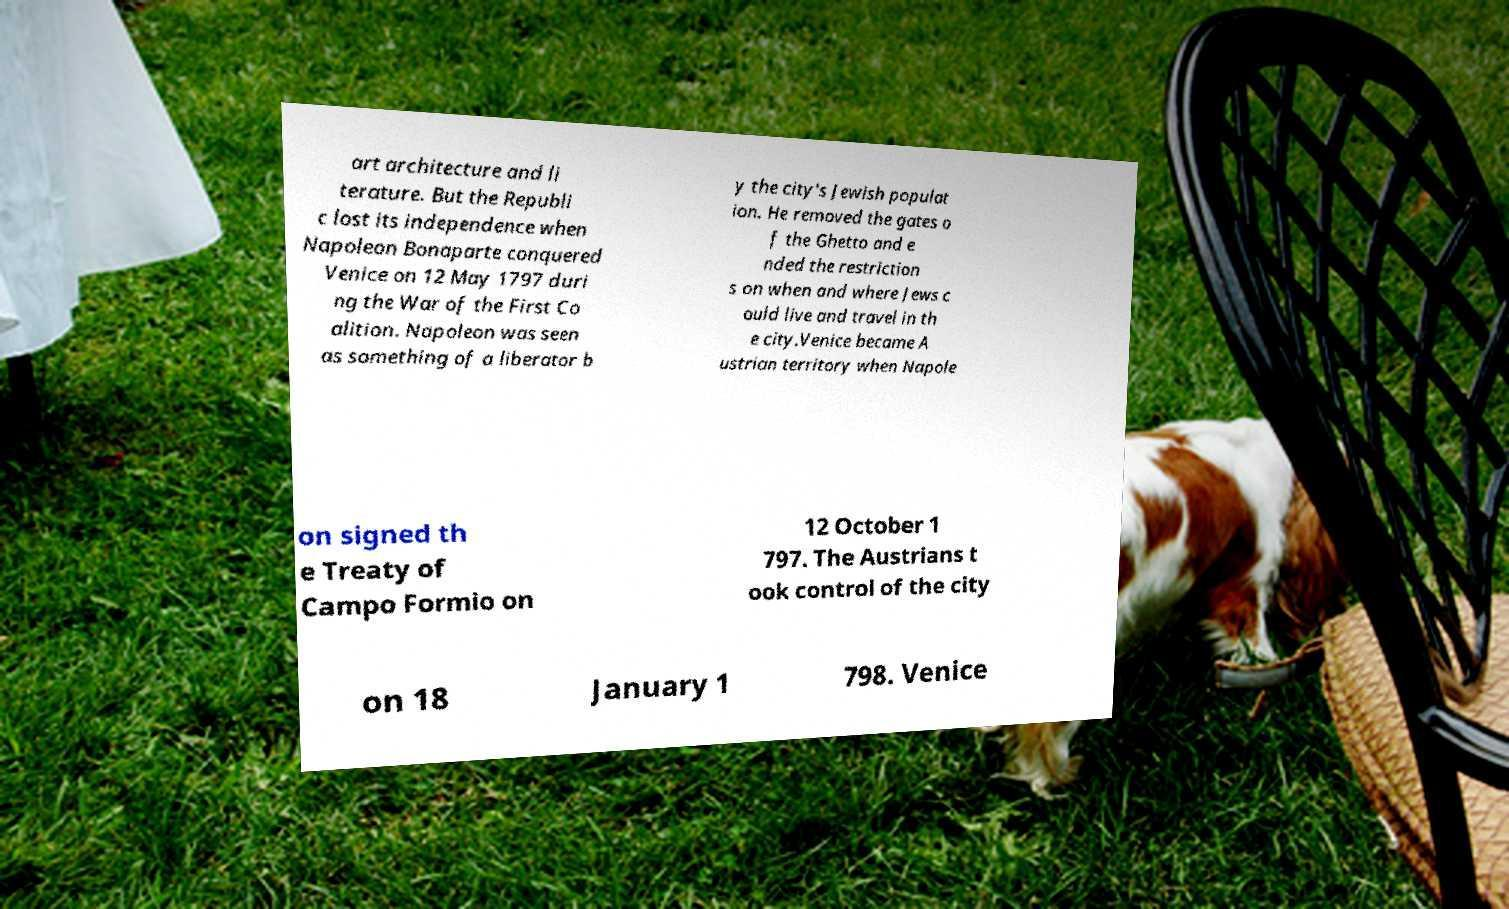Please identify and transcribe the text found in this image. art architecture and li terature. But the Republi c lost its independence when Napoleon Bonaparte conquered Venice on 12 May 1797 duri ng the War of the First Co alition. Napoleon was seen as something of a liberator b y the city's Jewish populat ion. He removed the gates o f the Ghetto and e nded the restriction s on when and where Jews c ould live and travel in th e city.Venice became A ustrian territory when Napole on signed th e Treaty of Campo Formio on 12 October 1 797. The Austrians t ook control of the city on 18 January 1 798. Venice 